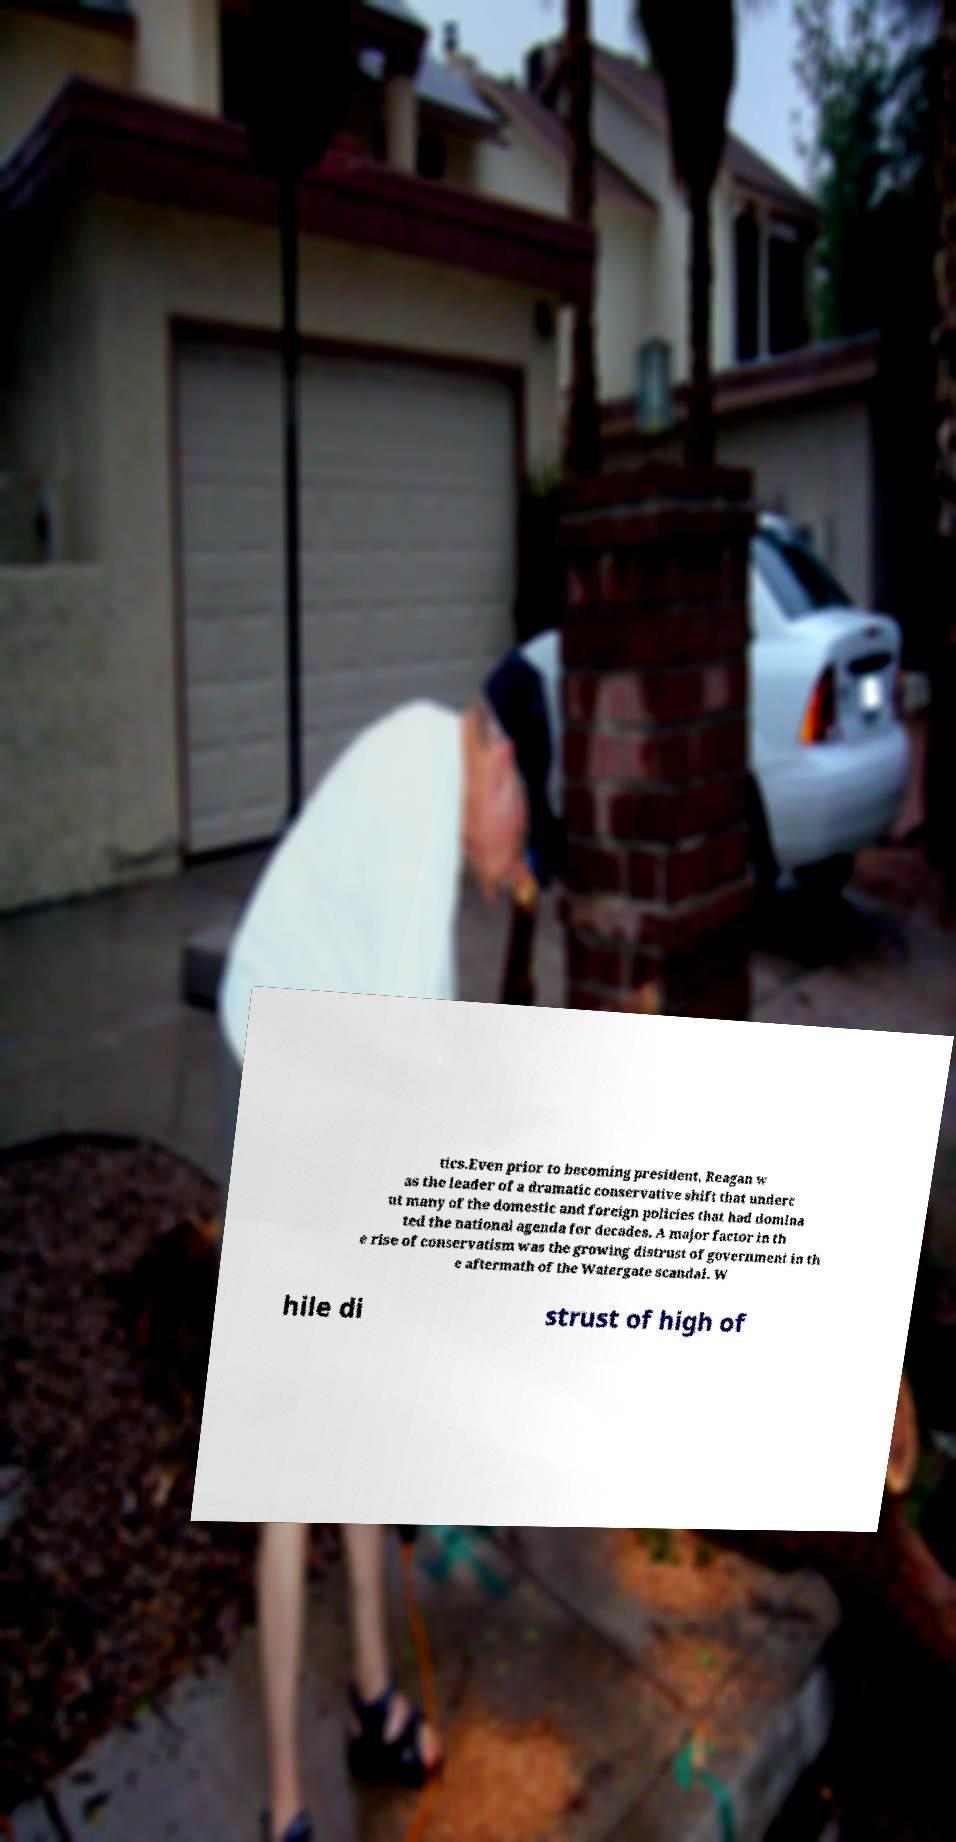Can you read and provide the text displayed in the image?This photo seems to have some interesting text. Can you extract and type it out for me? tics.Even prior to becoming president, Reagan w as the leader of a dramatic conservative shift that underc ut many of the domestic and foreign policies that had domina ted the national agenda for decades. A major factor in th e rise of conservatism was the growing distrust of government in th e aftermath of the Watergate scandal. W hile di strust of high of 